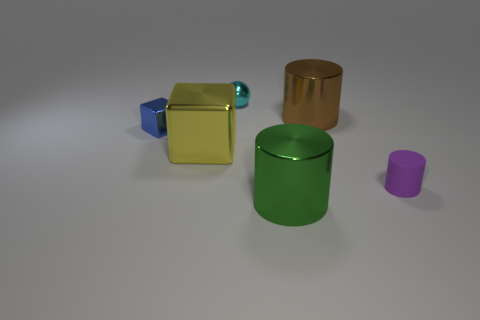Subtract all large cylinders. How many cylinders are left? 1 Subtract 1 balls. How many balls are left? 0 Subtract all yellow cubes. How many cubes are left? 1 Add 3 tiny blue shiny objects. How many objects exist? 9 Subtract all spheres. How many objects are left? 5 Add 4 tiny metal blocks. How many tiny metal blocks exist? 5 Subtract 1 brown cylinders. How many objects are left? 5 Subtract all purple balls. Subtract all green cubes. How many balls are left? 1 Subtract all tiny red metal cubes. Subtract all metal objects. How many objects are left? 1 Add 2 brown shiny objects. How many brown shiny objects are left? 3 